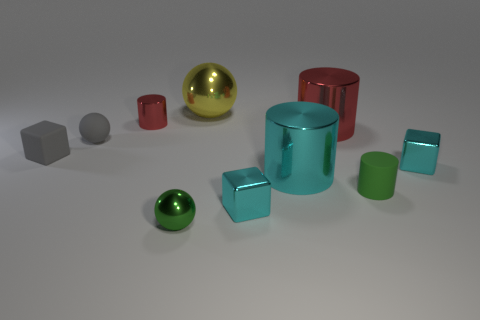Can you tell me about the lighting in this scene? The lighting in the scene is soft and diffused, coming from above, casting gentle shadows directly beneath the objects with a slight bias towards the front, hinting at a single, possibly elevated light source.  How does the lighting affect the appearance of the materials? The soft lighting highlights the unique textures of each material; it enhances the metallic sheen, deepens the hue of the plastics, and adds depth to the glass objects by creating subtle reflections and transparencies. 